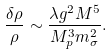<formula> <loc_0><loc_0><loc_500><loc_500>\frac { \delta \rho } { \rho } \sim \frac { \lambda g ^ { 2 } M ^ { 5 } } { M _ { p } ^ { 3 } m _ { \sigma } ^ { 2 } } .</formula> 